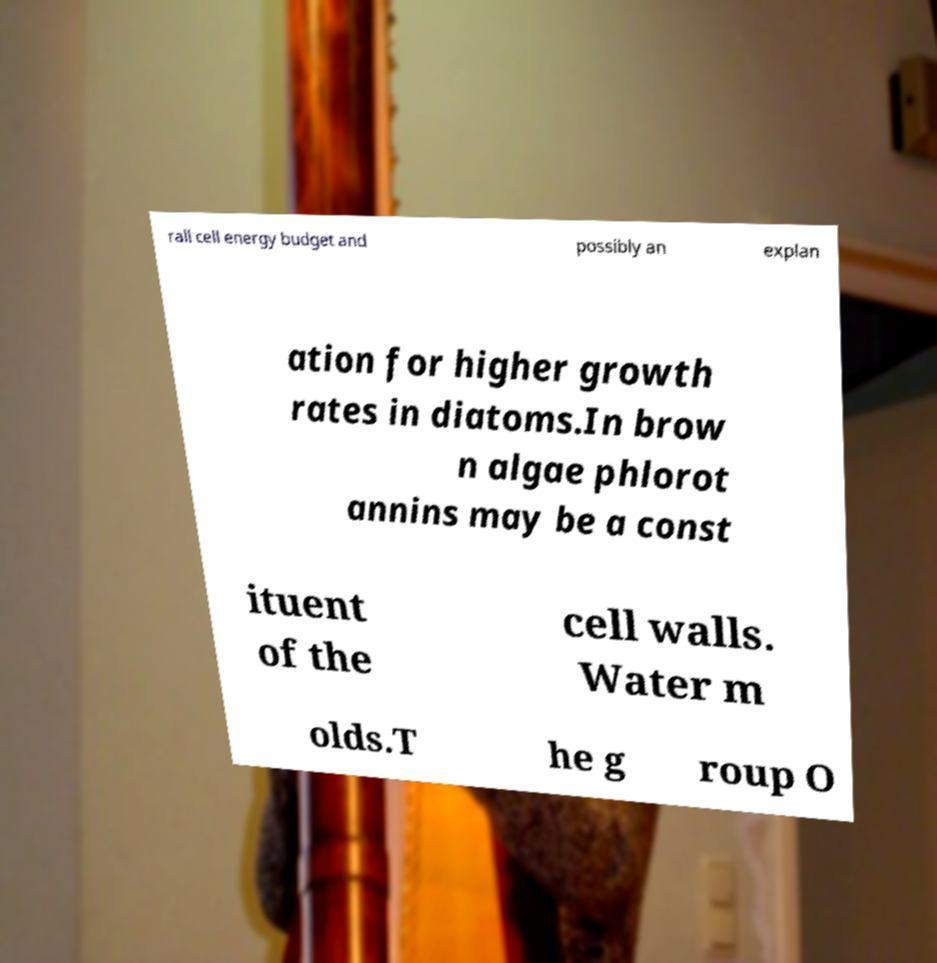For documentation purposes, I need the text within this image transcribed. Could you provide that? rall cell energy budget and possibly an explan ation for higher growth rates in diatoms.In brow n algae phlorot annins may be a const ituent of the cell walls. Water m olds.T he g roup O 